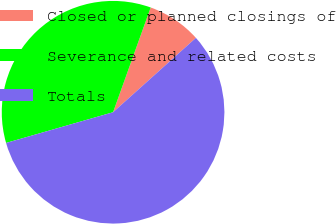Convert chart to OTSL. <chart><loc_0><loc_0><loc_500><loc_500><pie_chart><fcel>Closed or planned closings of<fcel>Severance and related costs<fcel>Totals<nl><fcel>7.87%<fcel>34.94%<fcel>57.2%<nl></chart> 